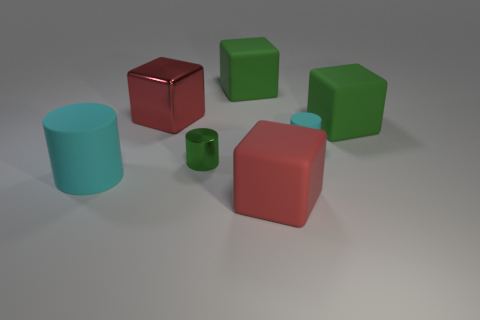Are there an equal number of big rubber cylinders that are on the right side of the large cyan rubber cylinder and big matte blocks in front of the small cyan matte cylinder?
Make the answer very short. No. There is a cyan object in front of the small cyan cylinder; is its shape the same as the small cyan matte object?
Your answer should be compact. Yes. What number of gray objects are cylinders or small objects?
Provide a succinct answer. 0. There is another big red object that is the same shape as the large red matte thing; what material is it?
Provide a succinct answer. Metal. What is the shape of the cyan object that is behind the big cylinder?
Ensure brevity in your answer.  Cylinder. Is there a gray thing that has the same material as the tiny cyan object?
Your answer should be very brief. No. Is the size of the shiny block the same as the green cylinder?
Keep it short and to the point. No. What number of cylinders are either tiny cyan things or small green objects?
Ensure brevity in your answer.  2. There is another big cube that is the same color as the metal block; what is it made of?
Your answer should be compact. Rubber. How many other large cyan objects have the same shape as the large cyan rubber thing?
Give a very brief answer. 0. 